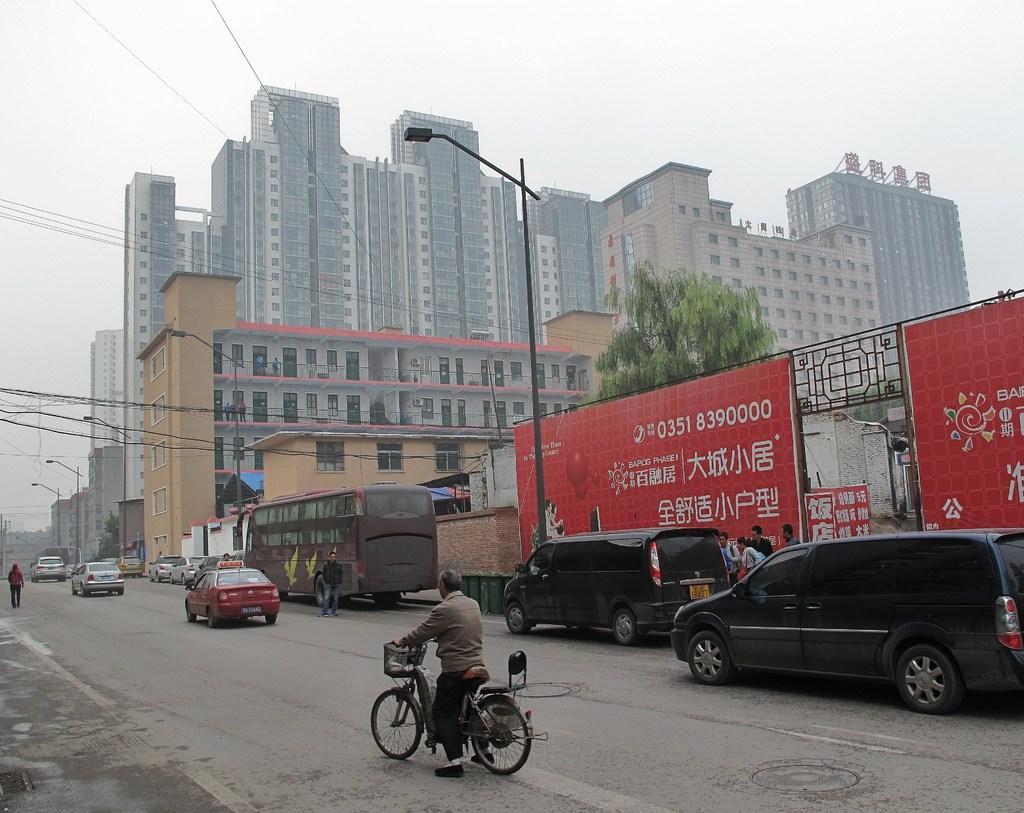Describe this image in one or two sentences. In this image we can see many buildings. There is a tree in the image. A person is riding a motorbike in the image. A person is walking on the road in the image. There are few advertising boards and street lights in the image. There are many electrical cables in the image. There are many vehicles in the image. 